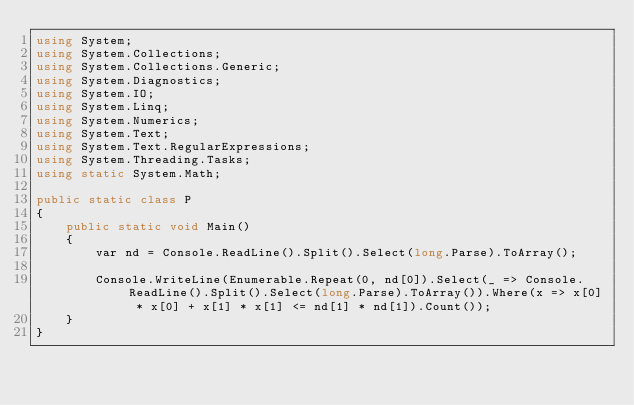Convert code to text. <code><loc_0><loc_0><loc_500><loc_500><_C#_>using System;
using System.Collections;
using System.Collections.Generic;
using System.Diagnostics;
using System.IO;
using System.Linq;
using System.Numerics;
using System.Text;
using System.Text.RegularExpressions;
using System.Threading.Tasks;
using static System.Math;

public static class P
{
    public static void Main()
    {
        var nd = Console.ReadLine().Split().Select(long.Parse).ToArray();

        Console.WriteLine(Enumerable.Repeat(0, nd[0]).Select(_ => Console.ReadLine().Split().Select(long.Parse).ToArray()).Where(x => x[0] * x[0] + x[1] * x[1] <= nd[1] * nd[1]).Count());
    }
}
</code> 